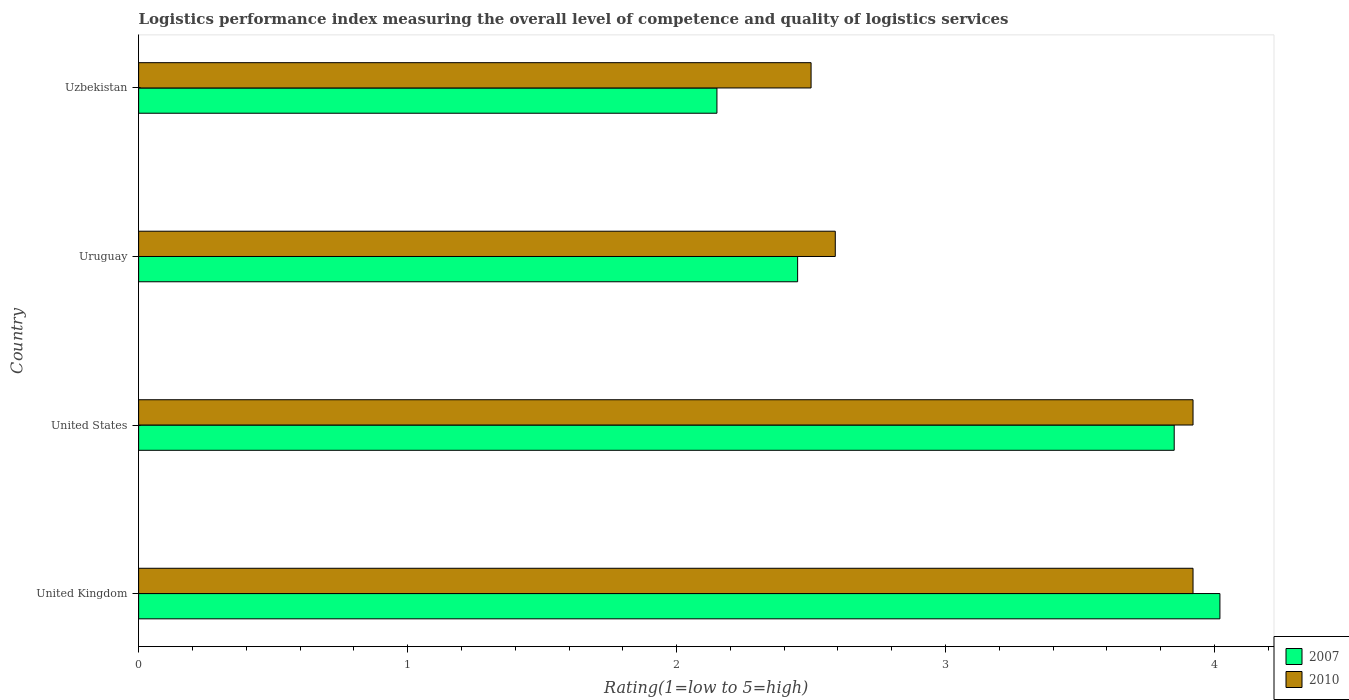How many different coloured bars are there?
Give a very brief answer. 2. Are the number of bars on each tick of the Y-axis equal?
Give a very brief answer. Yes. How many bars are there on the 4th tick from the bottom?
Keep it short and to the point. 2. What is the label of the 2nd group of bars from the top?
Make the answer very short. Uruguay. In how many cases, is the number of bars for a given country not equal to the number of legend labels?
Offer a very short reply. 0. What is the Logistic performance index in 2007 in Uzbekistan?
Your answer should be compact. 2.15. Across all countries, what is the maximum Logistic performance index in 2007?
Provide a short and direct response. 4.02. Across all countries, what is the minimum Logistic performance index in 2007?
Offer a very short reply. 2.15. In which country was the Logistic performance index in 2010 maximum?
Offer a terse response. United Kingdom. In which country was the Logistic performance index in 2010 minimum?
Keep it short and to the point. Uzbekistan. What is the total Logistic performance index in 2010 in the graph?
Offer a very short reply. 12.93. What is the difference between the Logistic performance index in 2007 in United States and that in Uzbekistan?
Offer a terse response. 1.7. What is the difference between the Logistic performance index in 2010 in Uruguay and the Logistic performance index in 2007 in United States?
Your answer should be compact. -1.26. What is the average Logistic performance index in 2010 per country?
Give a very brief answer. 3.23. What is the difference between the Logistic performance index in 2010 and Logistic performance index in 2007 in United Kingdom?
Keep it short and to the point. -0.1. What is the ratio of the Logistic performance index in 2010 in United Kingdom to that in United States?
Your answer should be very brief. 1. Is the Logistic performance index in 2007 in United Kingdom less than that in Uruguay?
Provide a short and direct response. No. What is the difference between the highest and the second highest Logistic performance index in 2007?
Your answer should be very brief. 0.17. What is the difference between the highest and the lowest Logistic performance index in 2007?
Your response must be concise. 1.87. What does the 2nd bar from the top in Uruguay represents?
Offer a terse response. 2007. What does the 2nd bar from the bottom in United States represents?
Offer a very short reply. 2010. Are the values on the major ticks of X-axis written in scientific E-notation?
Provide a short and direct response. No. Does the graph contain any zero values?
Offer a terse response. No. How are the legend labels stacked?
Offer a terse response. Vertical. What is the title of the graph?
Give a very brief answer. Logistics performance index measuring the overall level of competence and quality of logistics services. Does "1960" appear as one of the legend labels in the graph?
Provide a succinct answer. No. What is the label or title of the X-axis?
Provide a succinct answer. Rating(1=low to 5=high). What is the Rating(1=low to 5=high) in 2007 in United Kingdom?
Offer a terse response. 4.02. What is the Rating(1=low to 5=high) of 2010 in United Kingdom?
Offer a terse response. 3.92. What is the Rating(1=low to 5=high) of 2007 in United States?
Provide a short and direct response. 3.85. What is the Rating(1=low to 5=high) of 2010 in United States?
Ensure brevity in your answer.  3.92. What is the Rating(1=low to 5=high) in 2007 in Uruguay?
Offer a terse response. 2.45. What is the Rating(1=low to 5=high) in 2010 in Uruguay?
Give a very brief answer. 2.59. What is the Rating(1=low to 5=high) of 2007 in Uzbekistan?
Your response must be concise. 2.15. What is the Rating(1=low to 5=high) in 2010 in Uzbekistan?
Give a very brief answer. 2.5. Across all countries, what is the maximum Rating(1=low to 5=high) in 2007?
Provide a short and direct response. 4.02. Across all countries, what is the maximum Rating(1=low to 5=high) in 2010?
Provide a succinct answer. 3.92. Across all countries, what is the minimum Rating(1=low to 5=high) of 2007?
Make the answer very short. 2.15. What is the total Rating(1=low to 5=high) of 2007 in the graph?
Your answer should be compact. 12.47. What is the total Rating(1=low to 5=high) in 2010 in the graph?
Give a very brief answer. 12.93. What is the difference between the Rating(1=low to 5=high) in 2007 in United Kingdom and that in United States?
Your answer should be very brief. 0.17. What is the difference between the Rating(1=low to 5=high) of 2007 in United Kingdom and that in Uruguay?
Make the answer very short. 1.57. What is the difference between the Rating(1=low to 5=high) in 2010 in United Kingdom and that in Uruguay?
Your response must be concise. 1.33. What is the difference between the Rating(1=low to 5=high) of 2007 in United Kingdom and that in Uzbekistan?
Offer a very short reply. 1.87. What is the difference between the Rating(1=low to 5=high) of 2010 in United Kingdom and that in Uzbekistan?
Make the answer very short. 1.42. What is the difference between the Rating(1=low to 5=high) of 2007 in United States and that in Uruguay?
Keep it short and to the point. 1.4. What is the difference between the Rating(1=low to 5=high) of 2010 in United States and that in Uruguay?
Provide a succinct answer. 1.33. What is the difference between the Rating(1=low to 5=high) of 2010 in United States and that in Uzbekistan?
Offer a terse response. 1.42. What is the difference between the Rating(1=low to 5=high) of 2010 in Uruguay and that in Uzbekistan?
Ensure brevity in your answer.  0.09. What is the difference between the Rating(1=low to 5=high) of 2007 in United Kingdom and the Rating(1=low to 5=high) of 2010 in Uruguay?
Make the answer very short. 1.43. What is the difference between the Rating(1=low to 5=high) of 2007 in United Kingdom and the Rating(1=low to 5=high) of 2010 in Uzbekistan?
Provide a succinct answer. 1.52. What is the difference between the Rating(1=low to 5=high) of 2007 in United States and the Rating(1=low to 5=high) of 2010 in Uruguay?
Provide a short and direct response. 1.26. What is the difference between the Rating(1=low to 5=high) in 2007 in United States and the Rating(1=low to 5=high) in 2010 in Uzbekistan?
Ensure brevity in your answer.  1.35. What is the average Rating(1=low to 5=high) of 2007 per country?
Your answer should be compact. 3.12. What is the average Rating(1=low to 5=high) of 2010 per country?
Your answer should be compact. 3.23. What is the difference between the Rating(1=low to 5=high) of 2007 and Rating(1=low to 5=high) of 2010 in United Kingdom?
Offer a terse response. 0.1. What is the difference between the Rating(1=low to 5=high) in 2007 and Rating(1=low to 5=high) in 2010 in United States?
Provide a short and direct response. -0.07. What is the difference between the Rating(1=low to 5=high) in 2007 and Rating(1=low to 5=high) in 2010 in Uruguay?
Provide a succinct answer. -0.14. What is the difference between the Rating(1=low to 5=high) of 2007 and Rating(1=low to 5=high) of 2010 in Uzbekistan?
Keep it short and to the point. -0.35. What is the ratio of the Rating(1=low to 5=high) in 2007 in United Kingdom to that in United States?
Give a very brief answer. 1.04. What is the ratio of the Rating(1=low to 5=high) of 2010 in United Kingdom to that in United States?
Your answer should be very brief. 1. What is the ratio of the Rating(1=low to 5=high) of 2007 in United Kingdom to that in Uruguay?
Make the answer very short. 1.64. What is the ratio of the Rating(1=low to 5=high) of 2010 in United Kingdom to that in Uruguay?
Provide a succinct answer. 1.51. What is the ratio of the Rating(1=low to 5=high) in 2007 in United Kingdom to that in Uzbekistan?
Offer a very short reply. 1.87. What is the ratio of the Rating(1=low to 5=high) of 2010 in United Kingdom to that in Uzbekistan?
Offer a very short reply. 1.57. What is the ratio of the Rating(1=low to 5=high) in 2007 in United States to that in Uruguay?
Keep it short and to the point. 1.57. What is the ratio of the Rating(1=low to 5=high) of 2010 in United States to that in Uruguay?
Give a very brief answer. 1.51. What is the ratio of the Rating(1=low to 5=high) in 2007 in United States to that in Uzbekistan?
Your answer should be compact. 1.79. What is the ratio of the Rating(1=low to 5=high) in 2010 in United States to that in Uzbekistan?
Your answer should be very brief. 1.57. What is the ratio of the Rating(1=low to 5=high) in 2007 in Uruguay to that in Uzbekistan?
Your answer should be very brief. 1.14. What is the ratio of the Rating(1=low to 5=high) of 2010 in Uruguay to that in Uzbekistan?
Your answer should be compact. 1.04. What is the difference between the highest and the second highest Rating(1=low to 5=high) of 2007?
Make the answer very short. 0.17. What is the difference between the highest and the second highest Rating(1=low to 5=high) of 2010?
Your answer should be very brief. 0. What is the difference between the highest and the lowest Rating(1=low to 5=high) in 2007?
Offer a very short reply. 1.87. What is the difference between the highest and the lowest Rating(1=low to 5=high) in 2010?
Your answer should be very brief. 1.42. 